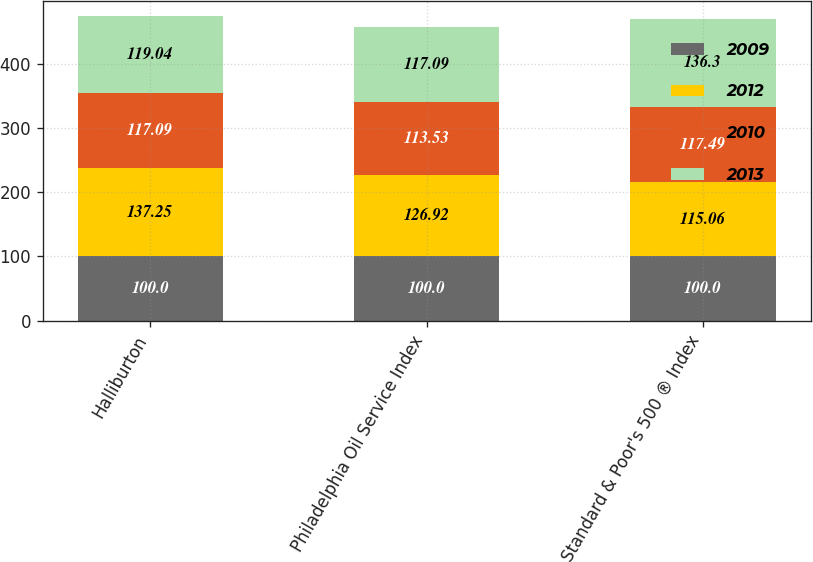Convert chart to OTSL. <chart><loc_0><loc_0><loc_500><loc_500><stacked_bar_chart><ecel><fcel>Halliburton<fcel>Philadelphia Oil Service Index<fcel>Standard & Poor's 500 ® Index<nl><fcel>2009<fcel>100<fcel>100<fcel>100<nl><fcel>2012<fcel>137.25<fcel>126.92<fcel>115.06<nl><fcel>2010<fcel>117.09<fcel>113.53<fcel>117.49<nl><fcel>2013<fcel>119.04<fcel>117.09<fcel>136.3<nl></chart> 